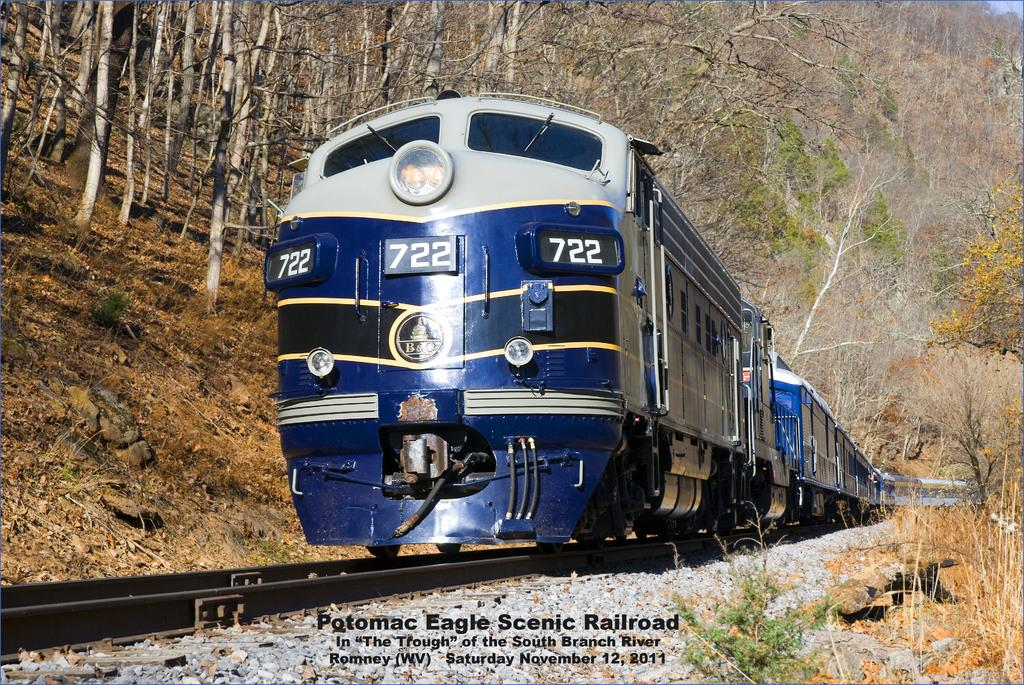What is the main subject of the image? The main subject of the image is a train on the track. What can be found at the bottom of the image? There are stones and plants visible at the bottom of the image. What is present in the background of the image? There are trees, plants, and stones in the background of the image. Is there any text in the image? Yes, there is text at the bottom of the image. What type of bait is being used by the train in the image? There is no bait present in the image, as it features a train on a track. Can you tell me how many vessels are visible in the image? There are no vessels present in the image; it features a train on a track and various elements in the foreground and background. 